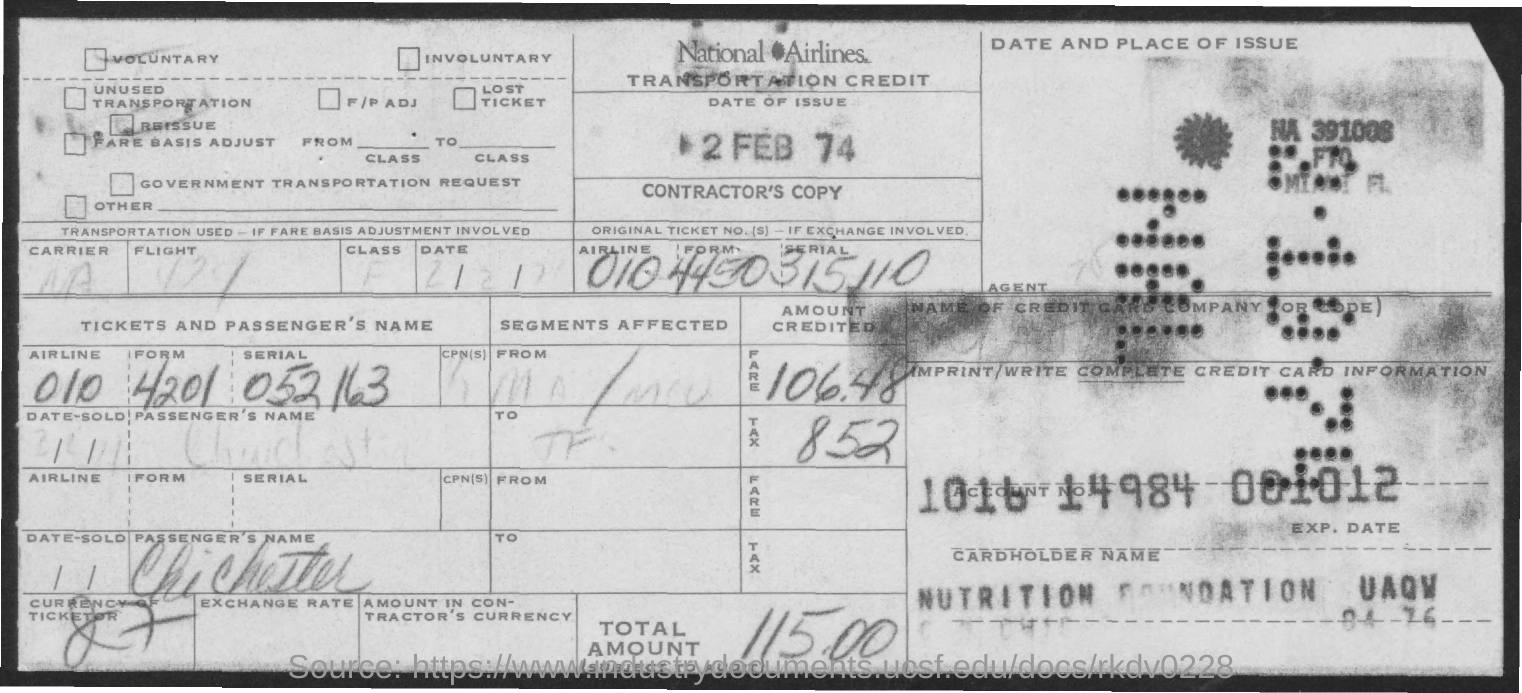What is the date of issue?
Provide a short and direct response. 2 feb 74. What is the name of the airlines?
Your answer should be compact. National Airlines. What is the total amount?
Provide a short and direct response. 115.00. What is the amount of tax?
Offer a very short reply. 8.52. 